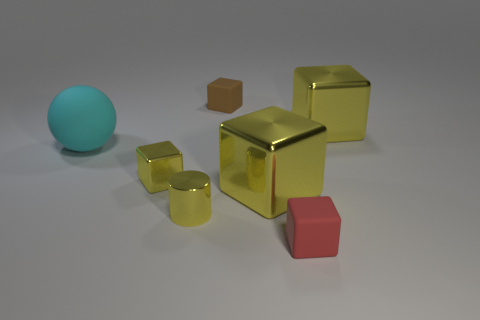Subtract all red balls. How many yellow cubes are left? 3 Subtract all brown cubes. How many cubes are left? 4 Subtract all tiny brown rubber cubes. How many cubes are left? 4 Subtract 2 blocks. How many blocks are left? 3 Subtract all blue cubes. Subtract all brown cylinders. How many cubes are left? 5 Add 3 red metallic cylinders. How many objects exist? 10 Subtract all cubes. How many objects are left? 2 Add 7 tiny blue cylinders. How many tiny blue cylinders exist? 7 Subtract 0 cyan cylinders. How many objects are left? 7 Subtract all small yellow cubes. Subtract all large yellow things. How many objects are left? 4 